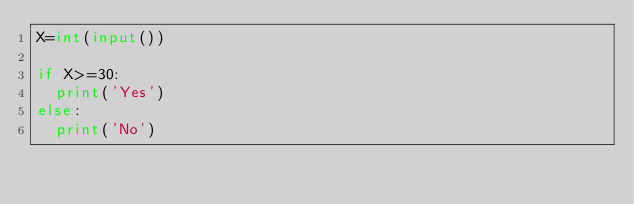<code> <loc_0><loc_0><loc_500><loc_500><_Python_>X=int(input())

if X>=30:
  print('Yes')
else:
  print('No')</code> 